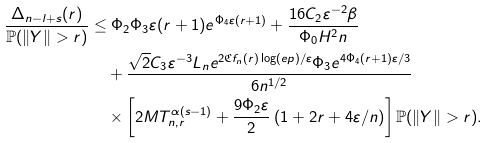<formula> <loc_0><loc_0><loc_500><loc_500>\frac { \Delta _ { n - l + s } ( r ) } { \mathbb { P } ( \| Y \| > r ) } & \leq \Phi _ { 2 } \Phi _ { 3 } \varepsilon ( r + 1 ) e ^ { \Phi _ { 4 } \varepsilon ( r + 1 ) } + \frac { 1 6 C _ { 2 } \varepsilon ^ { - 2 } \beta } { \Phi _ { 0 } H ^ { 2 } n } \\ & \quad + \frac { \sqrt { 2 } C _ { 3 } \varepsilon ^ { - 3 } L _ { n } e ^ { 2 \mathfrak { C } f _ { n } ( r ) \log ( e p ) / \varepsilon } \Phi _ { 3 } e ^ { 4 \Phi _ { 4 } ( r + 1 ) \varepsilon / 3 } } { 6 n ^ { 1 / 2 } } \\ & \quad \times \left [ 2 M T _ { n , r } ^ { \alpha ( s - 1 ) } + \frac { 9 \Phi _ { 2 } \varepsilon } { 2 } \left ( 1 + 2 r + { 4 \varepsilon } / { n } \right ) \right ] \mathbb { P } ( \| Y \| > r ) .</formula> 